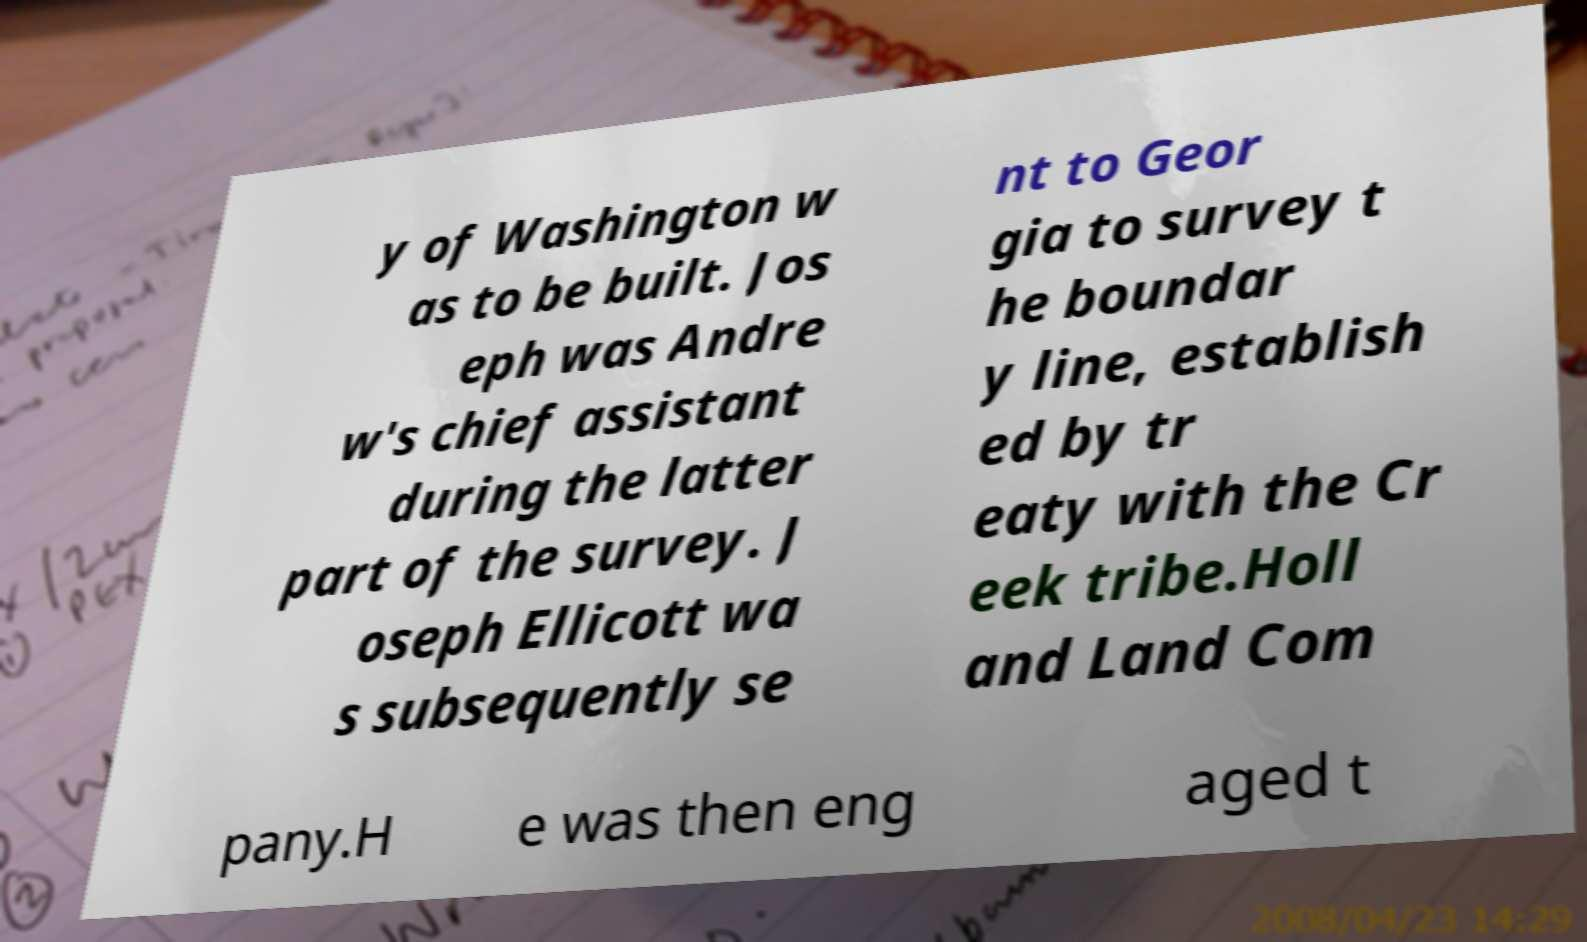Please identify and transcribe the text found in this image. y of Washington w as to be built. Jos eph was Andre w's chief assistant during the latter part of the survey. J oseph Ellicott wa s subsequently se nt to Geor gia to survey t he boundar y line, establish ed by tr eaty with the Cr eek tribe.Holl and Land Com pany.H e was then eng aged t 